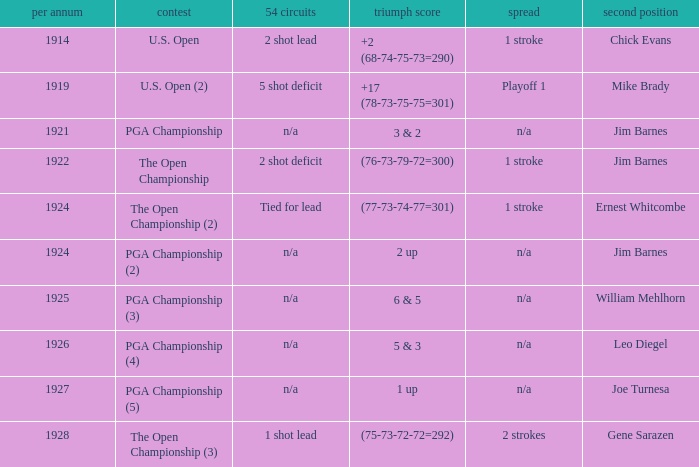WHAT YEAR DID MIKE BRADY GET RUNNER-UP? 1919.0. 